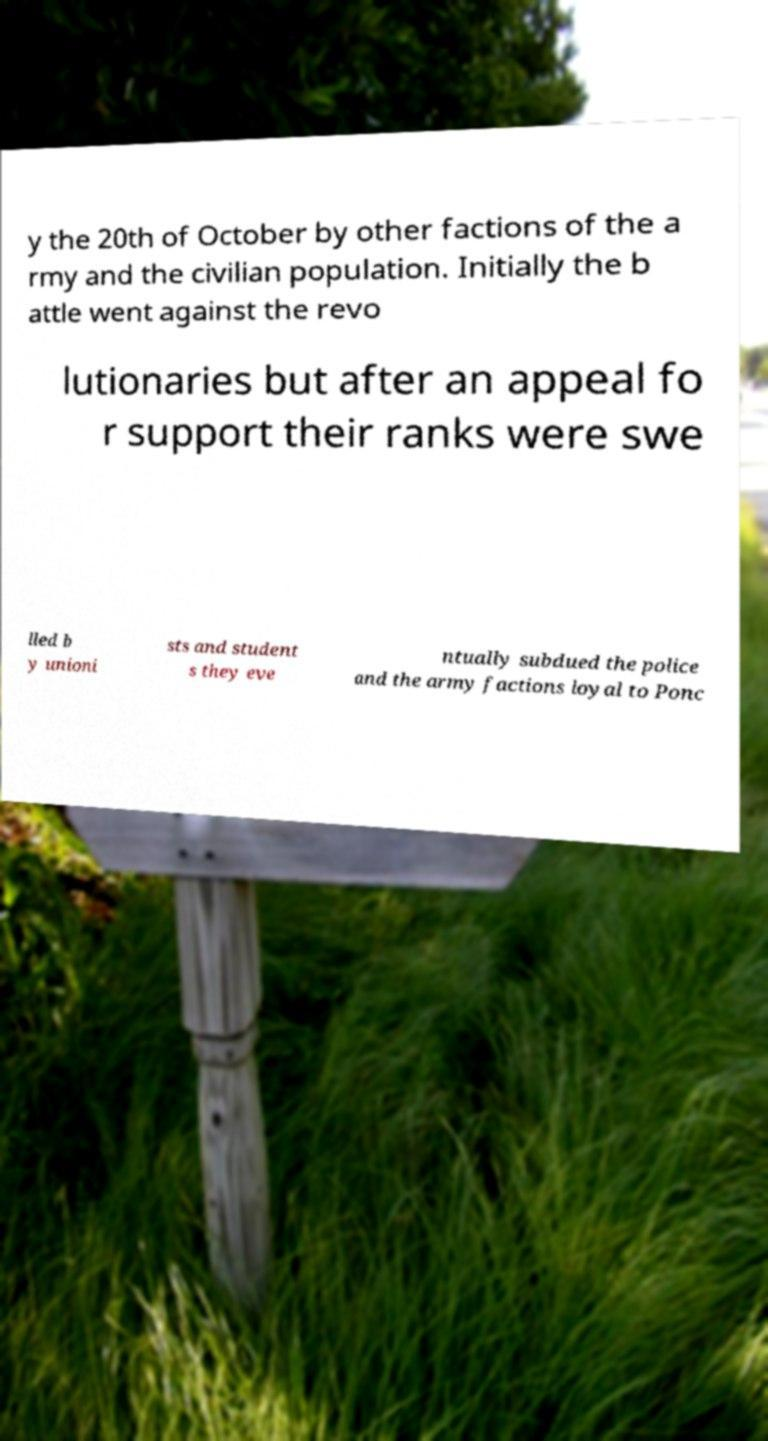Please identify and transcribe the text found in this image. y the 20th of October by other factions of the a rmy and the civilian population. Initially the b attle went against the revo lutionaries but after an appeal fo r support their ranks were swe lled b y unioni sts and student s they eve ntually subdued the police and the army factions loyal to Ponc 